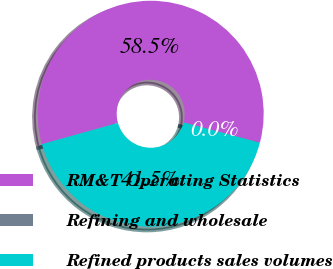<chart> <loc_0><loc_0><loc_500><loc_500><pie_chart><fcel>RM&T Operating Statistics<fcel>Refining and wholesale<fcel>Refined products sales volumes<nl><fcel>58.46%<fcel>0.01%<fcel>41.53%<nl></chart> 